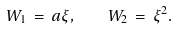Convert formula to latex. <formula><loc_0><loc_0><loc_500><loc_500>W _ { 1 } \, = \, a \xi , \quad W _ { 2 } \, = \, \xi ^ { 2 } .</formula> 